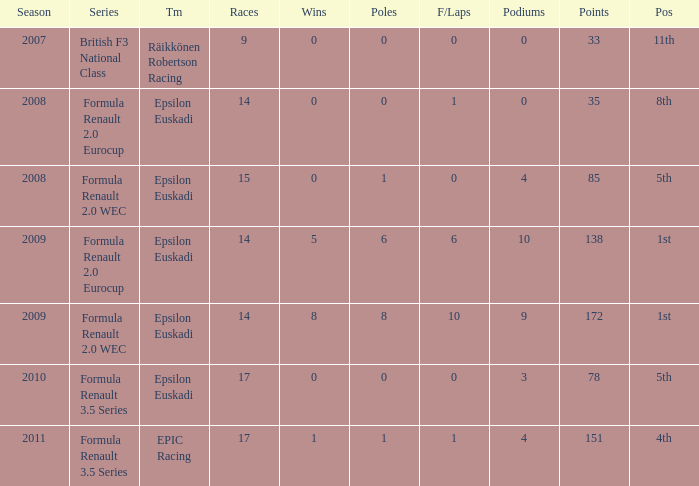How many podiums when he was in the british f3 national class series? 1.0. 